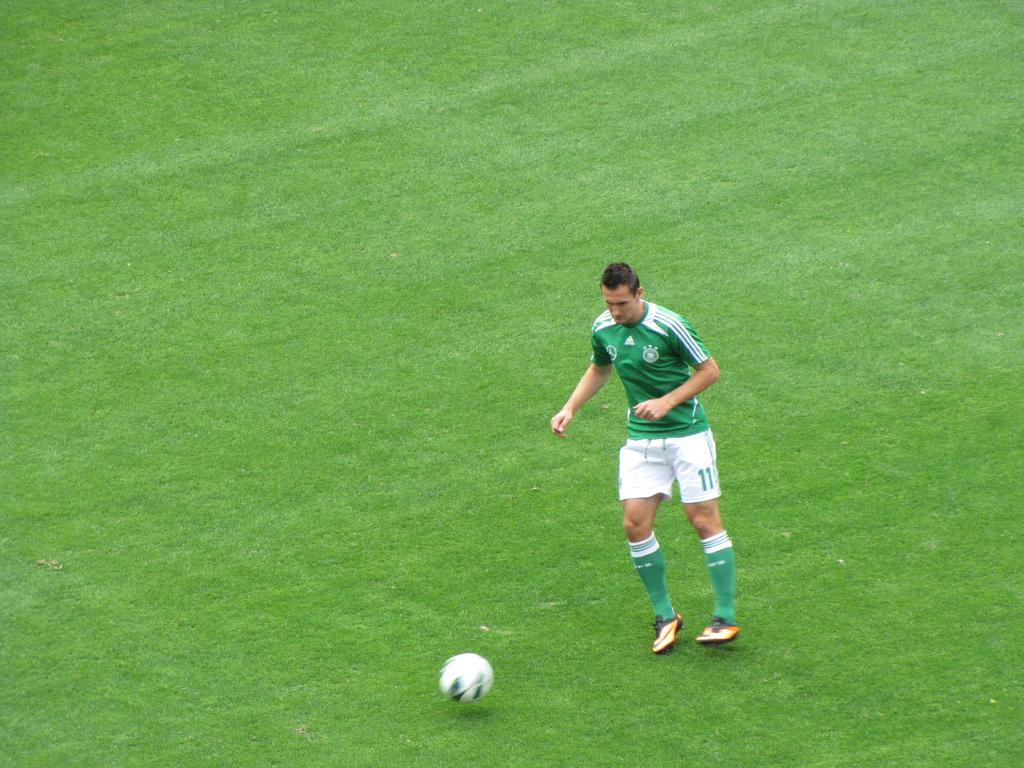Provide a one-sentence caption for the provided image. Soccer player #11 runs with the ball on the pitch. 